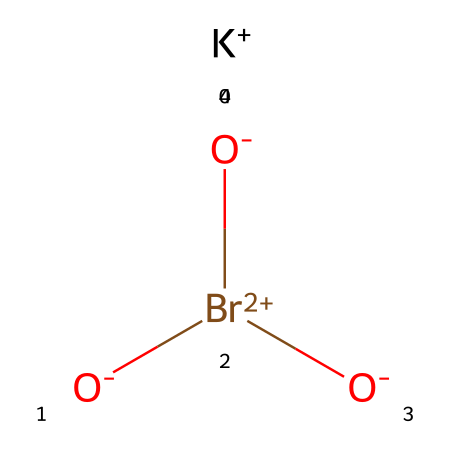How many oxygen atoms are present in this compound? By examining the SMILES representation, we see the notation "[O-]" indicates one oxygen atom, and "Br(=O)=O" shows two additional oxygen atoms bonded to bromine. Therefore, we count a total of three oxygen atoms.
Answer: three What is the central atom in this structure? In the given SMILES, the bromine atom (Br) is located in the center of the structure, as it is bonded to three oxygens and has a distinctive higher oxidation state.
Answer: bromine What type of ion is involved in this chemical? The "[K+]" notation indicates that there is a potassium ion with a positive charge, which is essential for the compound's functionality as it provides charge balance with the other components.
Answer: cation How does the presence of bromine influence the flour improver properties? The presence of bromine in the form of potassium bromate contributes to dough strengthening by promoting gluten formation through oxidation, enhancing the baking performance of flour.
Answer: gluten formation What charge does the oxygen have in this structure? The oxygen is indicated by "[O-]", meaning it carries a negative charge, which is crucial for its role in balancing the overall charge of the potassium bromate molecule.
Answer: negative How many total bonds are connected to the bromine atom? In the structure, bromine is bonded to three oxygen atoms (two through double bonds and one through a single bond). Hence, there are three total bonds associated with bromine.
Answer: three 